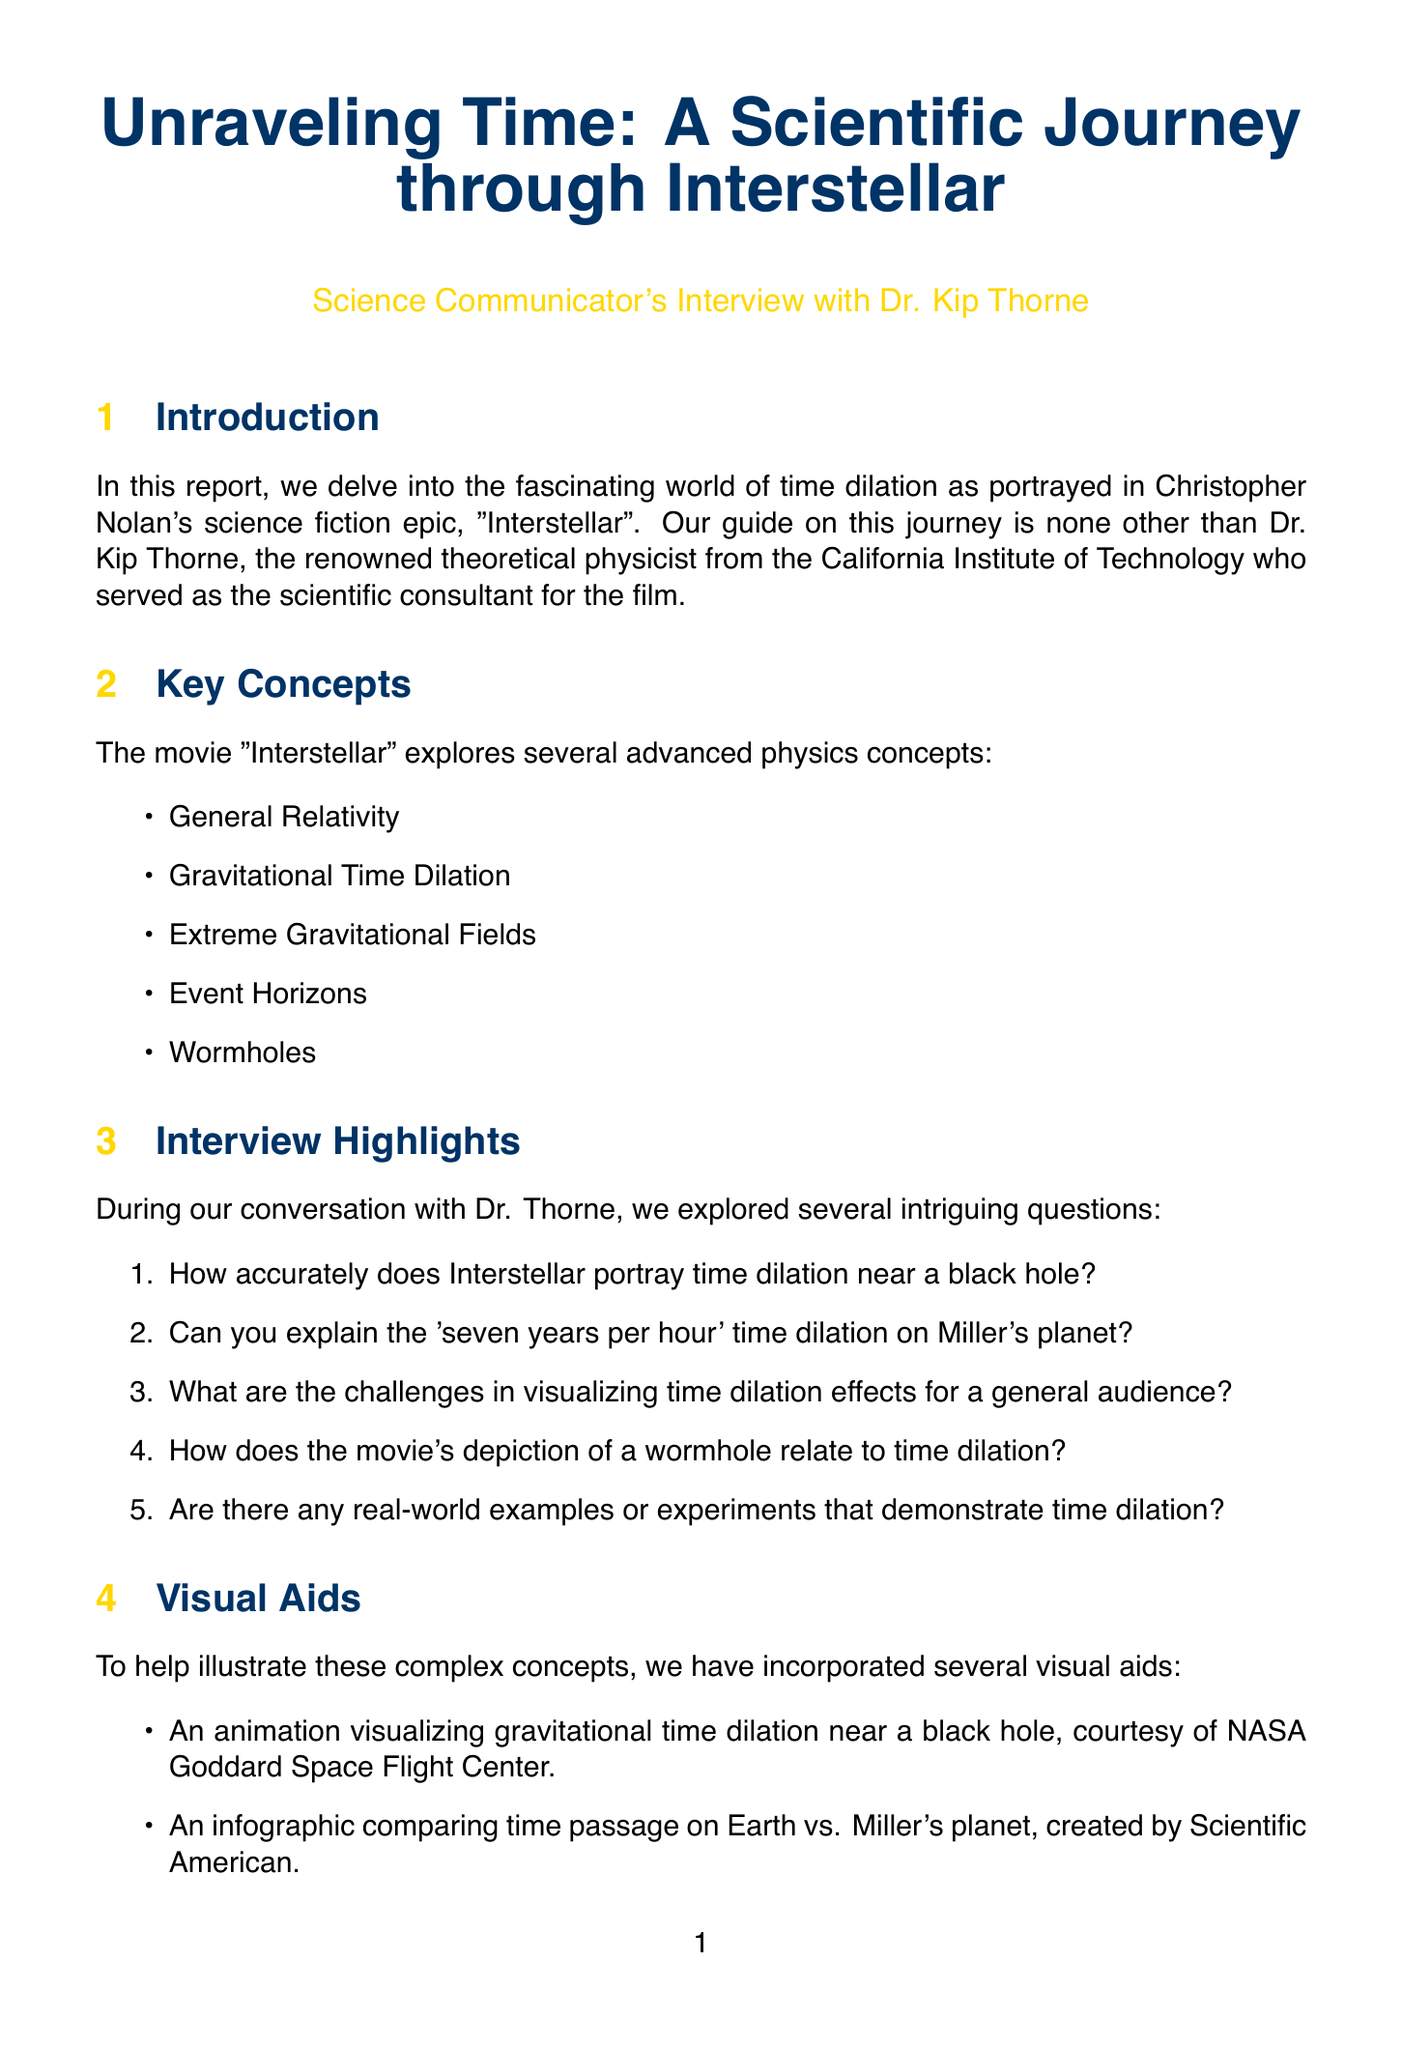How accurately does Interstellar portray time dilation near a black hole? This question asks for specific feedback from Dr. Thorne regarding the portrayal accuracy of time dilation in the film.
Answer: Answer not provided in the document What is the time dilation effect on Miller's planet? This question refers to the specific time dilation mentioned in the interview.
Answer: Seven years per hour Who is the scientific consultant for Interstellar? This question seeks to identify the expert involved in the film's scientific accuracy.
Answer: Dr. Kip Thorne Which planet is depicted with extreme time dilation effects? This question looks for a particular setting within the movie that illustrates time dilation.
Answer: Miller's planet What is the source of the chart on gravitational field strength and time dilation? This question aims to find the origin or creator of a specific visual aid used in the report.
Answer: European Space Agency (ESA) What interactive tool is suggested for exploring time dilation effects? This question is focused on an engagement activity mentioned in the document.
Answer: Interactive Time Dilation Calculator When was "The Science of Interstellar" published? This question requests a specific publication date for a related scientific paper.
Answer: 2014 What experiment tested predictions of Einstein's General Theory of Relativity? This question seeks to identify a real-world application related to the concepts discussed.
Answer: Gravity Probe B What type of visual aid shows the relationship between time passage on Earth and Miller's planet? This question is focused on identifying the type of visual representation used in the document.
Answer: Infographic 